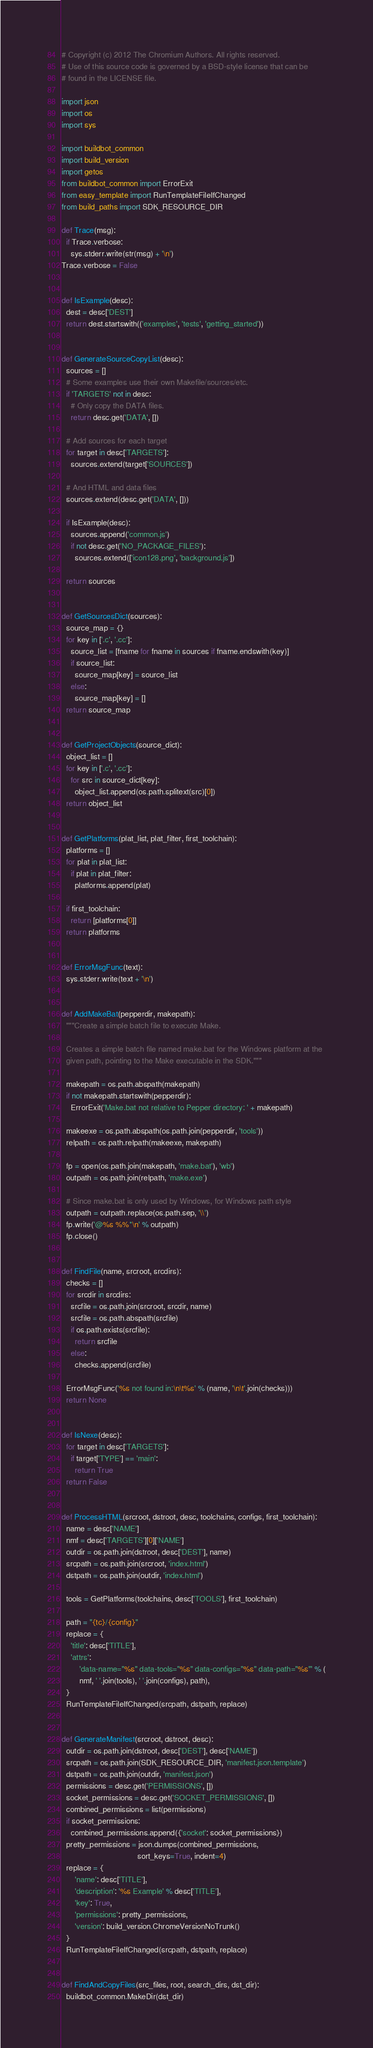<code> <loc_0><loc_0><loc_500><loc_500><_Python_># Copyright (c) 2012 The Chromium Authors. All rights reserved.
# Use of this source code is governed by a BSD-style license that can be
# found in the LICENSE file.

import json
import os
import sys

import buildbot_common
import build_version
import getos
from buildbot_common import ErrorExit
from easy_template import RunTemplateFileIfChanged
from build_paths import SDK_RESOURCE_DIR

def Trace(msg):
  if Trace.verbose:
    sys.stderr.write(str(msg) + '\n')
Trace.verbose = False


def IsExample(desc):
  dest = desc['DEST']
  return dest.startswith(('examples', 'tests', 'getting_started'))


def GenerateSourceCopyList(desc):
  sources = []
  # Some examples use their own Makefile/sources/etc.
  if 'TARGETS' not in desc:
    # Only copy the DATA files.
    return desc.get('DATA', [])

  # Add sources for each target
  for target in desc['TARGETS']:
    sources.extend(target['SOURCES'])

  # And HTML and data files
  sources.extend(desc.get('DATA', []))

  if IsExample(desc):
    sources.append('common.js')
    if not desc.get('NO_PACKAGE_FILES'):
      sources.extend(['icon128.png', 'background.js'])

  return sources


def GetSourcesDict(sources):
  source_map = {}
  for key in ['.c', '.cc']:
    source_list = [fname for fname in sources if fname.endswith(key)]
    if source_list:
      source_map[key] = source_list
    else:
      source_map[key] = []
  return source_map


def GetProjectObjects(source_dict):
  object_list = []
  for key in ['.c', '.cc']:
    for src in source_dict[key]:
      object_list.append(os.path.splitext(src)[0])
  return object_list


def GetPlatforms(plat_list, plat_filter, first_toolchain):
  platforms = []
  for plat in plat_list:
    if plat in plat_filter:
      platforms.append(plat)

  if first_toolchain:
    return [platforms[0]]
  return platforms


def ErrorMsgFunc(text):
  sys.stderr.write(text + '\n')


def AddMakeBat(pepperdir, makepath):
  """Create a simple batch file to execute Make.

  Creates a simple batch file named make.bat for the Windows platform at the
  given path, pointing to the Make executable in the SDK."""

  makepath = os.path.abspath(makepath)
  if not makepath.startswith(pepperdir):
    ErrorExit('Make.bat not relative to Pepper directory: ' + makepath)

  makeexe = os.path.abspath(os.path.join(pepperdir, 'tools'))
  relpath = os.path.relpath(makeexe, makepath)

  fp = open(os.path.join(makepath, 'make.bat'), 'wb')
  outpath = os.path.join(relpath, 'make.exe')

  # Since make.bat is only used by Windows, for Windows path style
  outpath = outpath.replace(os.path.sep, '\\')
  fp.write('@%s %%*\n' % outpath)
  fp.close()


def FindFile(name, srcroot, srcdirs):
  checks = []
  for srcdir in srcdirs:
    srcfile = os.path.join(srcroot, srcdir, name)
    srcfile = os.path.abspath(srcfile)
    if os.path.exists(srcfile):
      return srcfile
    else:
      checks.append(srcfile)

  ErrorMsgFunc('%s not found in:\n\t%s' % (name, '\n\t'.join(checks)))
  return None


def IsNexe(desc):
  for target in desc['TARGETS']:
    if target['TYPE'] == 'main':
      return True
  return False


def ProcessHTML(srcroot, dstroot, desc, toolchains, configs, first_toolchain):
  name = desc['NAME']
  nmf = desc['TARGETS'][0]['NAME']
  outdir = os.path.join(dstroot, desc['DEST'], name)
  srcpath = os.path.join(srcroot, 'index.html')
  dstpath = os.path.join(outdir, 'index.html')

  tools = GetPlatforms(toolchains, desc['TOOLS'], first_toolchain)

  path = "{tc}/{config}"
  replace = {
    'title': desc['TITLE'],
    'attrs':
        'data-name="%s" data-tools="%s" data-configs="%s" data-path="%s"' % (
        nmf, ' '.join(tools), ' '.join(configs), path),
  }
  RunTemplateFileIfChanged(srcpath, dstpath, replace)


def GenerateManifest(srcroot, dstroot, desc):
  outdir = os.path.join(dstroot, desc['DEST'], desc['NAME'])
  srcpath = os.path.join(SDK_RESOURCE_DIR, 'manifest.json.template')
  dstpath = os.path.join(outdir, 'manifest.json')
  permissions = desc.get('PERMISSIONS', [])
  socket_permissions = desc.get('SOCKET_PERMISSIONS', [])
  combined_permissions = list(permissions)
  if socket_permissions:
    combined_permissions.append({'socket': socket_permissions})
  pretty_permissions = json.dumps(combined_permissions,
                                  sort_keys=True, indent=4)
  replace = {
      'name': desc['TITLE'],
      'description': '%s Example' % desc['TITLE'],
      'key': True,
      'permissions': pretty_permissions,
      'version': build_version.ChromeVersionNoTrunk()
  }
  RunTemplateFileIfChanged(srcpath, dstpath, replace)


def FindAndCopyFiles(src_files, root, search_dirs, dst_dir):
  buildbot_common.MakeDir(dst_dir)</code> 